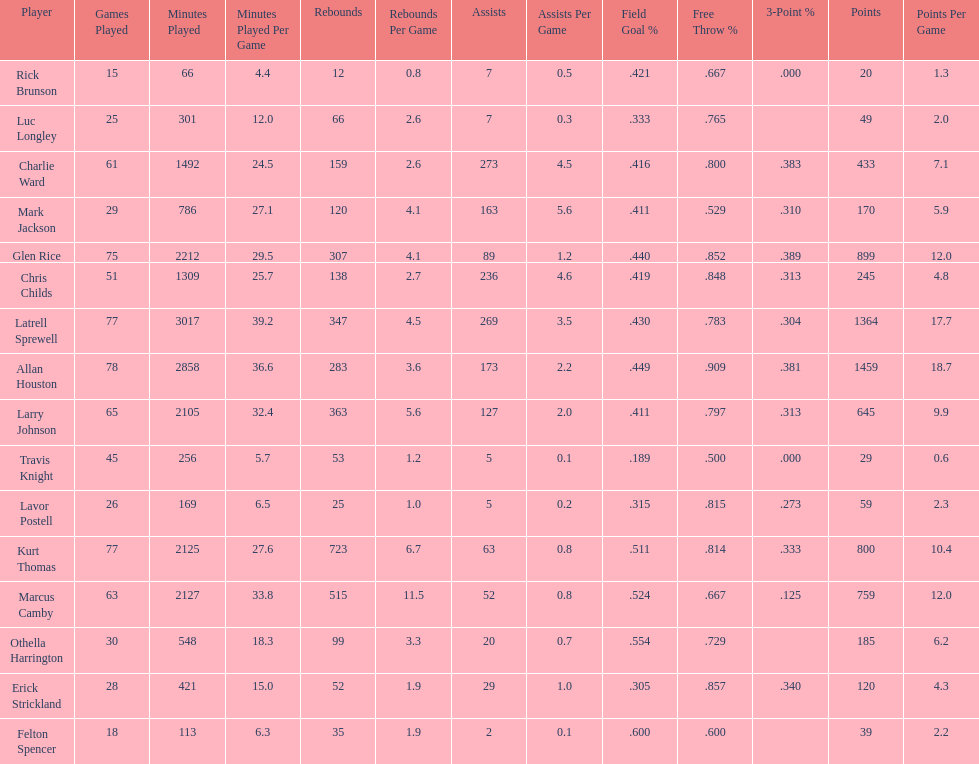How many games did larry johnson play? 65. 